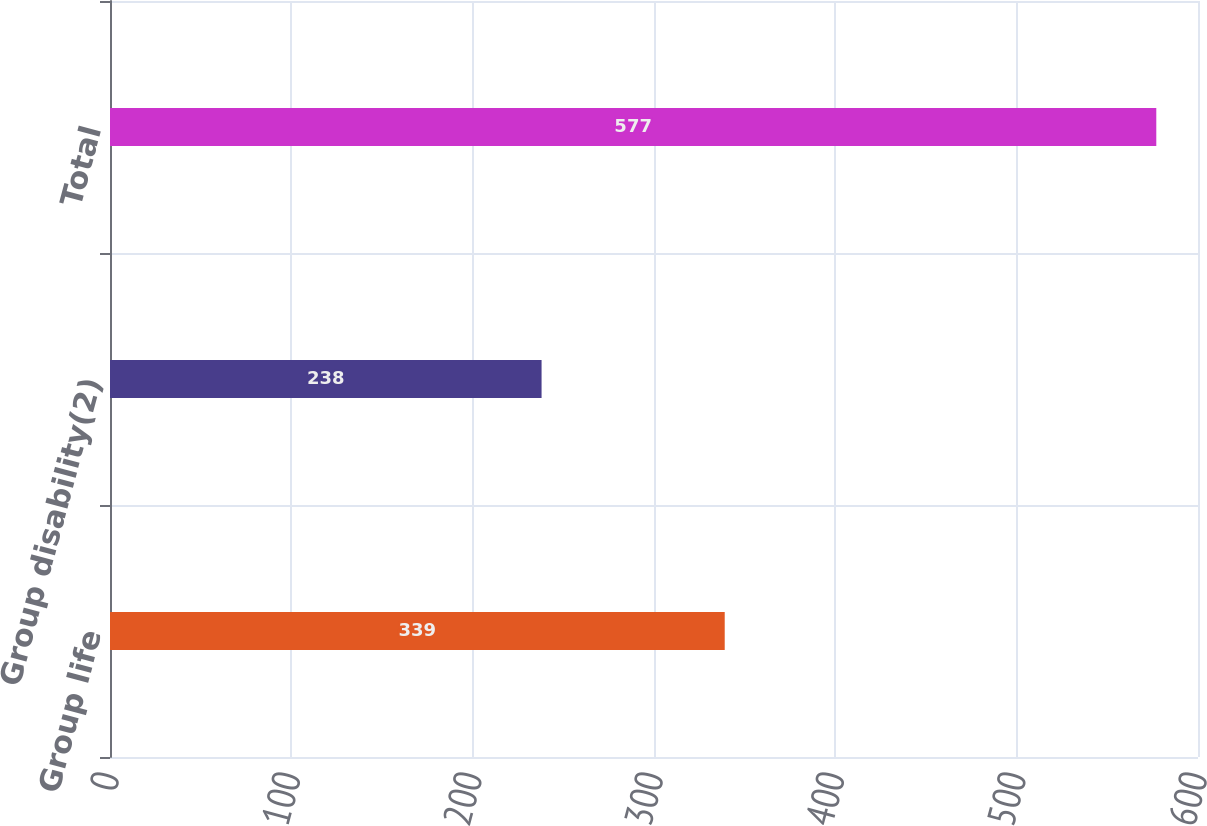Convert chart to OTSL. <chart><loc_0><loc_0><loc_500><loc_500><bar_chart><fcel>Group life<fcel>Group disability(2)<fcel>Total<nl><fcel>339<fcel>238<fcel>577<nl></chart> 